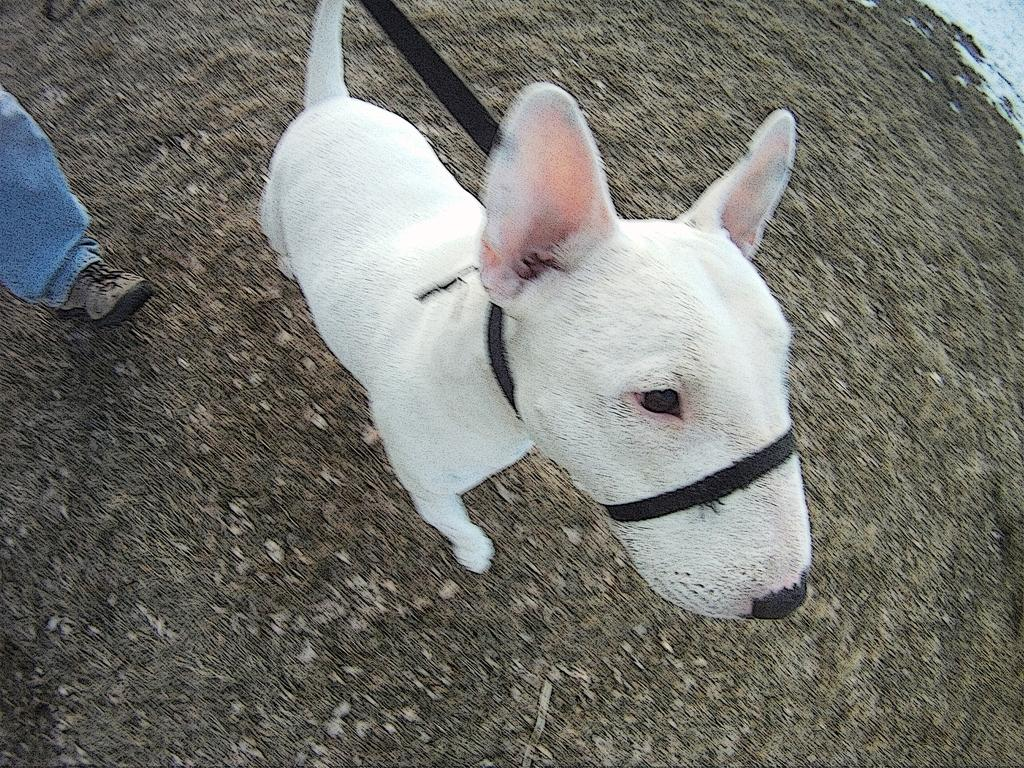What type of animal is in the image? There is a dog in the image. What color is the dog? The dog is white in color. What is the dog doing in the image? The dog is standing. Is there anything attached to the dog in the image? Yes, there is a black color belt attached to the dog. Can you see any part of a person in the image? Yes, a leg of a person is visible in the left top corner of the image. Where is the crib located in the image? There is no crib present in the image. Can you see a tiger in the image? No, there is no tiger in the image; it features a dog. 